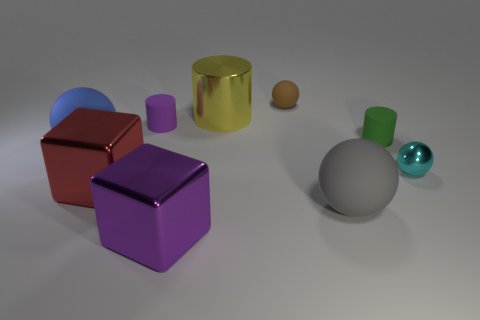What might be the function of the grouped objects if they were actual items? If these objects were real, they could serve various functions based on their shapes: the cylinder and cube could be containers or storage units, the spheres might be decorative objects like vases or paperweights, and the remaining shapes could also have artistic or practical uses depending on their material and scale. How would you describe the lighting in this scene and its effect on the objects? The lighting in the scene is diffused with a gentle gradient from the top right, casting soft shadows that enhance the three-dimensional quality of each object. It reveals the texture and reflects off the shinier surfaces, giving a sense of the material characteristics of the objects. 